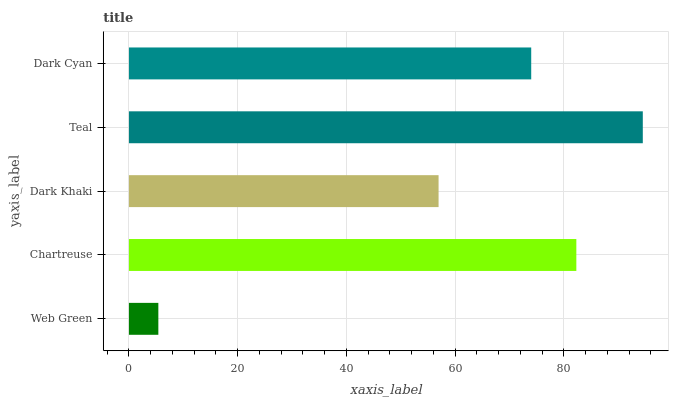Is Web Green the minimum?
Answer yes or no. Yes. Is Teal the maximum?
Answer yes or no. Yes. Is Chartreuse the minimum?
Answer yes or no. No. Is Chartreuse the maximum?
Answer yes or no. No. Is Chartreuse greater than Web Green?
Answer yes or no. Yes. Is Web Green less than Chartreuse?
Answer yes or no. Yes. Is Web Green greater than Chartreuse?
Answer yes or no. No. Is Chartreuse less than Web Green?
Answer yes or no. No. Is Dark Cyan the high median?
Answer yes or no. Yes. Is Dark Cyan the low median?
Answer yes or no. Yes. Is Web Green the high median?
Answer yes or no. No. Is Dark Khaki the low median?
Answer yes or no. No. 